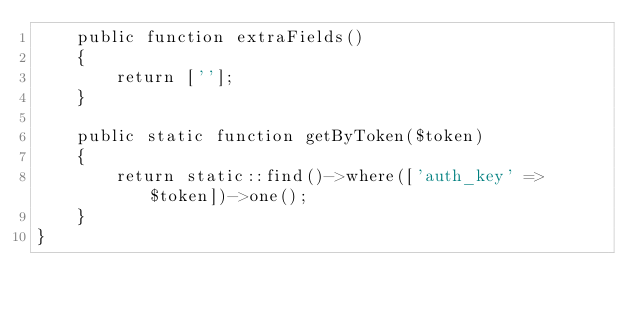Convert code to text. <code><loc_0><loc_0><loc_500><loc_500><_PHP_>    public function extraFields()
    {
        return [''];
    }

    public static function getByToken($token)
    {
        return static::find()->where(['auth_key' => $token])->one();
    }
}</code> 